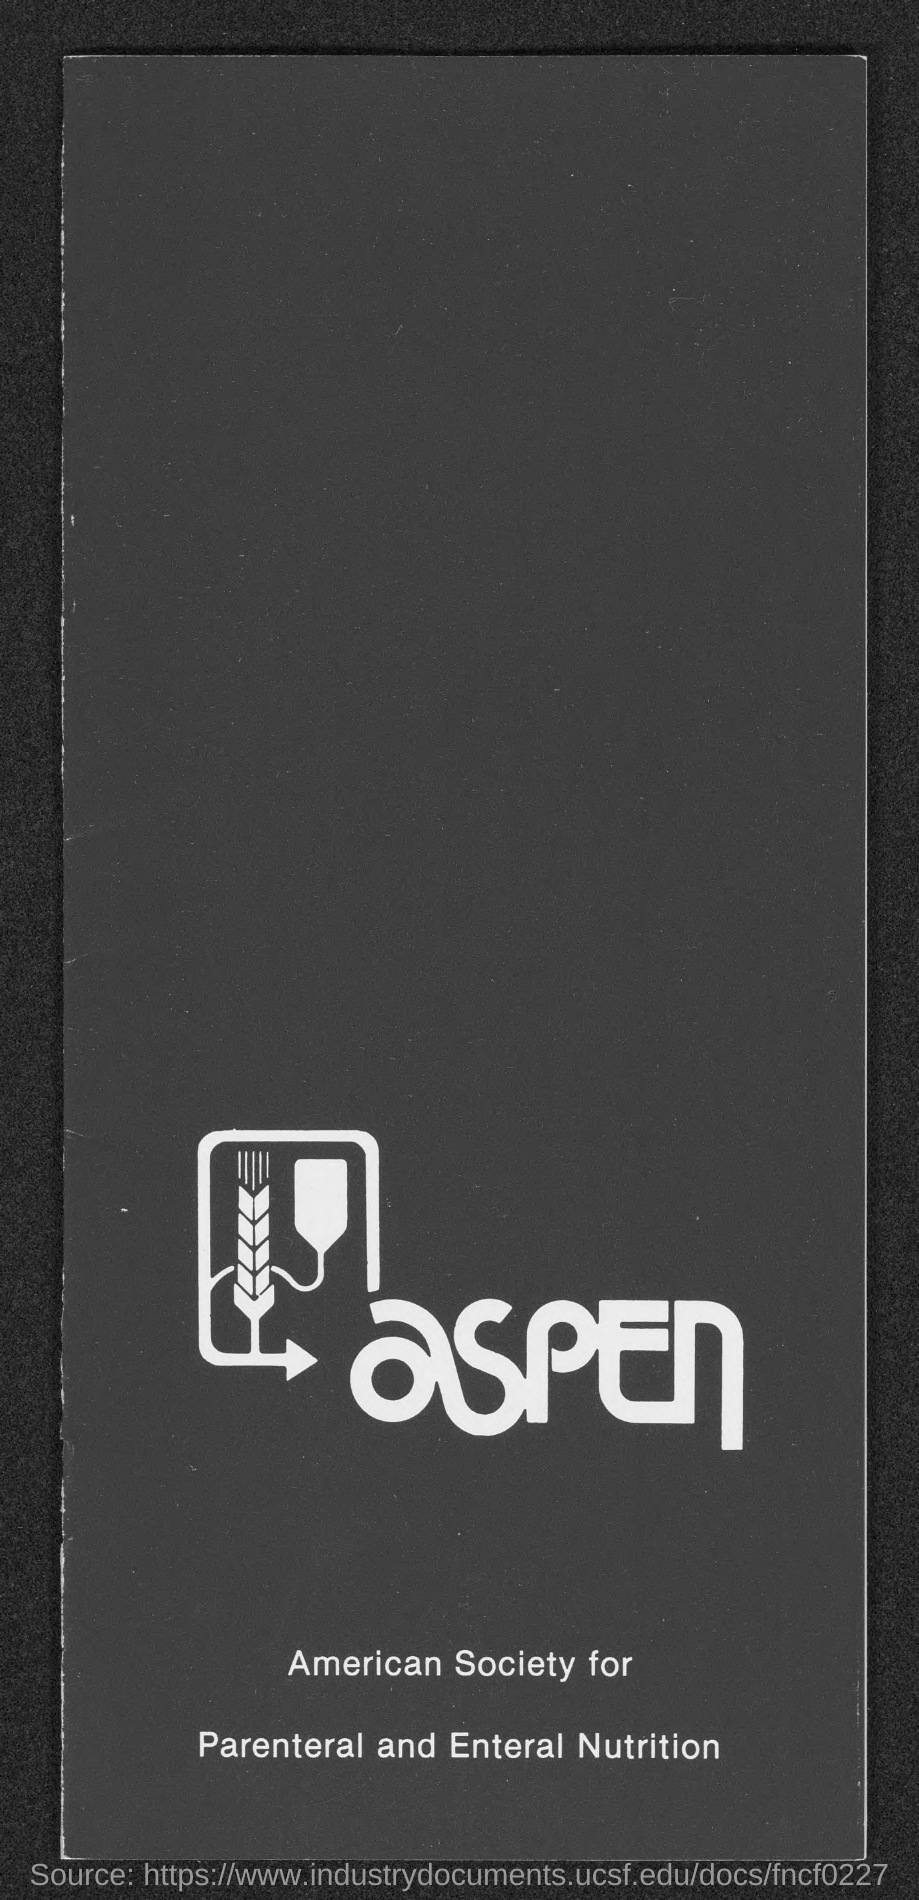Highlight a few significant elements in this photo. American Society for Parenteral and Enteral Nutrition (ASPEN) is a medical professional organization dedicated to advancing the field of nutrition support. 